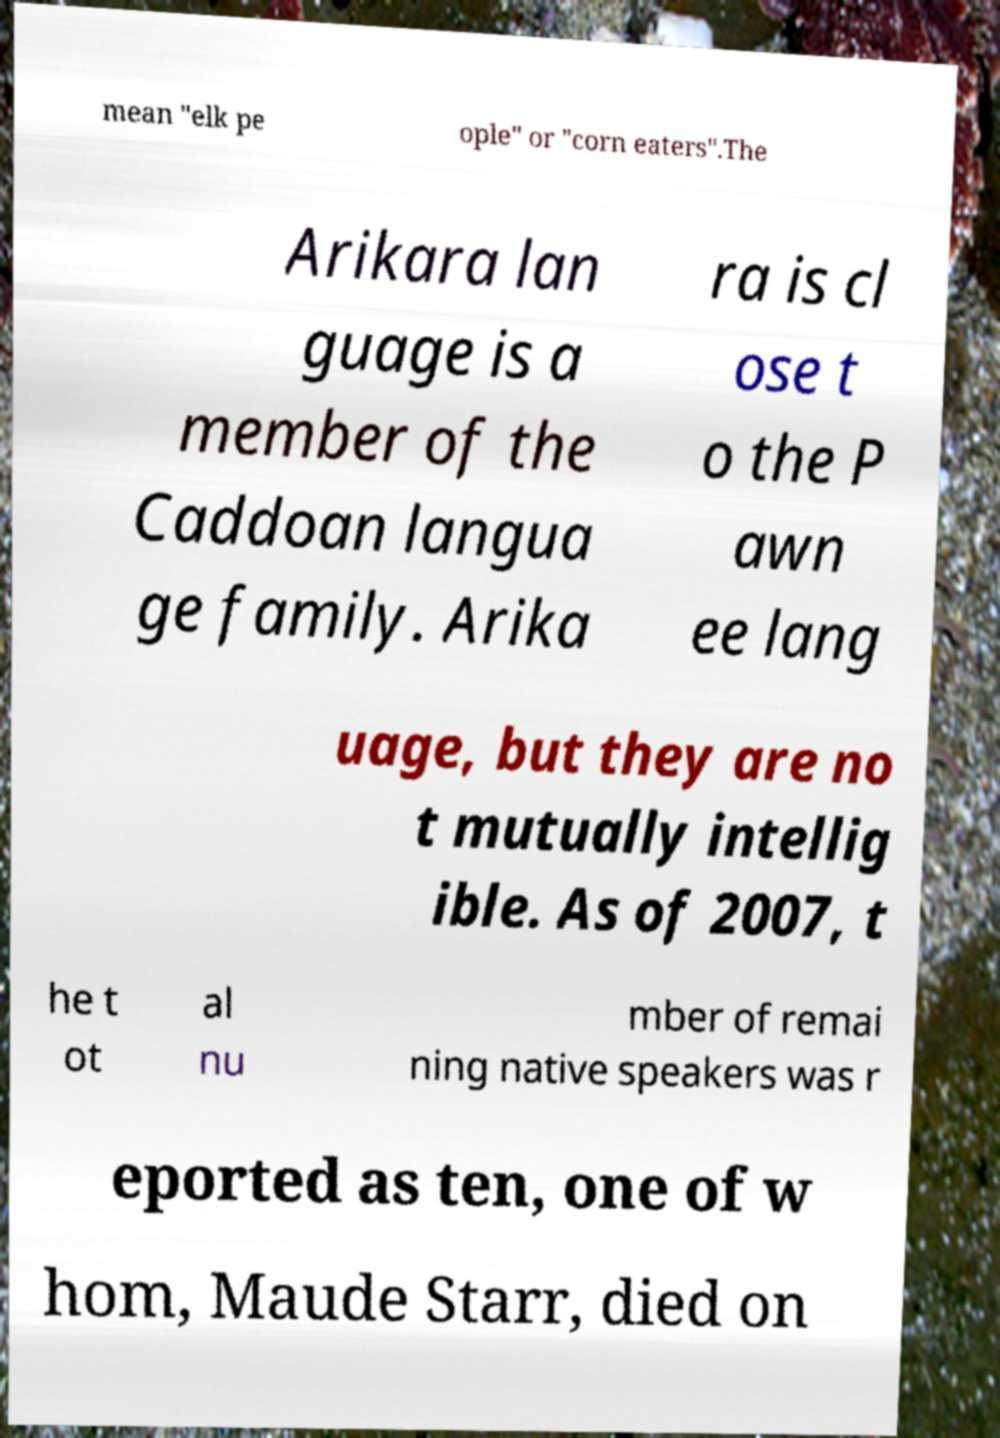There's text embedded in this image that I need extracted. Can you transcribe it verbatim? mean "elk pe ople" or "corn eaters".The Arikara lan guage is a member of the Caddoan langua ge family. Arika ra is cl ose t o the P awn ee lang uage, but they are no t mutually intellig ible. As of 2007, t he t ot al nu mber of remai ning native speakers was r eported as ten, one of w hom, Maude Starr, died on 